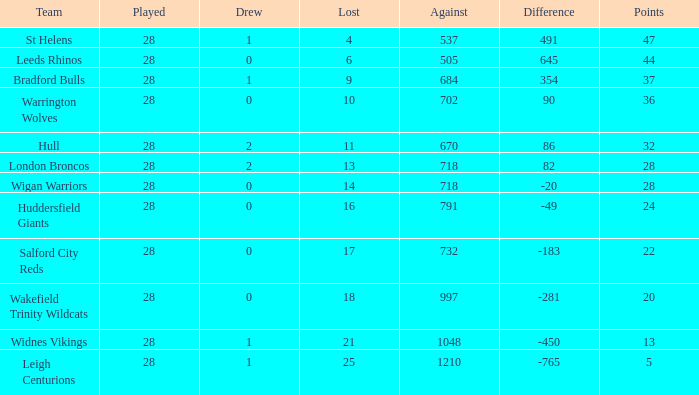What is the average points for a team that lost 4 and played more than 28 games? None. 